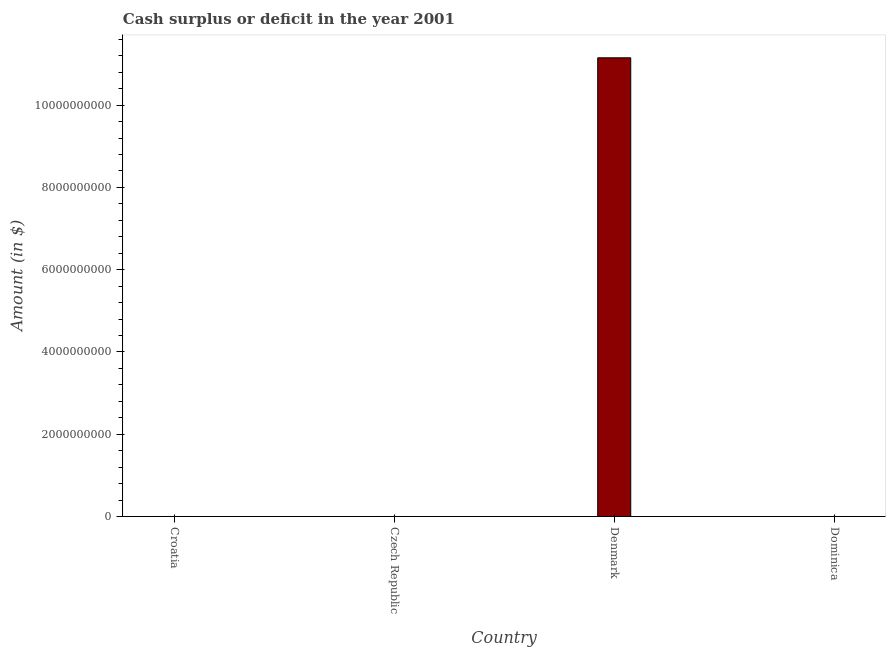What is the title of the graph?
Your response must be concise. Cash surplus or deficit in the year 2001. What is the label or title of the Y-axis?
Make the answer very short. Amount (in $). What is the cash surplus or deficit in Denmark?
Make the answer very short. 1.12e+1. Across all countries, what is the maximum cash surplus or deficit?
Provide a succinct answer. 1.12e+1. Across all countries, what is the minimum cash surplus or deficit?
Your answer should be very brief. 0. What is the sum of the cash surplus or deficit?
Your answer should be very brief. 1.12e+1. What is the average cash surplus or deficit per country?
Your answer should be very brief. 2.79e+09. What is the median cash surplus or deficit?
Ensure brevity in your answer.  0. In how many countries, is the cash surplus or deficit greater than 800000000 $?
Offer a very short reply. 1. What is the difference between the highest and the lowest cash surplus or deficit?
Your answer should be compact. 1.12e+1. How many bars are there?
Your answer should be compact. 1. Are all the bars in the graph horizontal?
Offer a terse response. No. Are the values on the major ticks of Y-axis written in scientific E-notation?
Provide a succinct answer. No. What is the Amount (in $) in Croatia?
Ensure brevity in your answer.  0. What is the Amount (in $) of Czech Republic?
Your answer should be very brief. 0. What is the Amount (in $) of Denmark?
Give a very brief answer. 1.12e+1. What is the Amount (in $) in Dominica?
Ensure brevity in your answer.  0. 